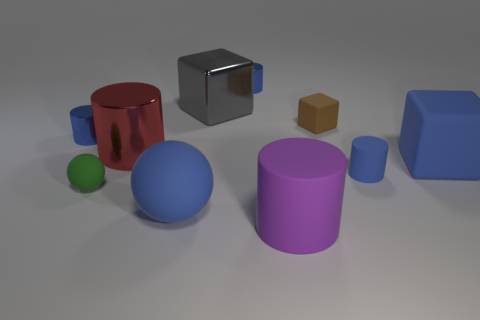How many blue cylinders must be subtracted to get 1 blue cylinders? 2 Subtract all red metallic cylinders. How many cylinders are left? 4 Subtract 1 cylinders. How many cylinders are left? 4 Subtract all brown blocks. How many blocks are left? 2 Subtract all balls. How many objects are left? 8 Subtract all yellow blocks. How many gray spheres are left? 0 Subtract all small gray metal cylinders. Subtract all balls. How many objects are left? 8 Add 5 large rubber cubes. How many large rubber cubes are left? 6 Add 10 small yellow cylinders. How many small yellow cylinders exist? 10 Subtract 1 red cylinders. How many objects are left? 9 